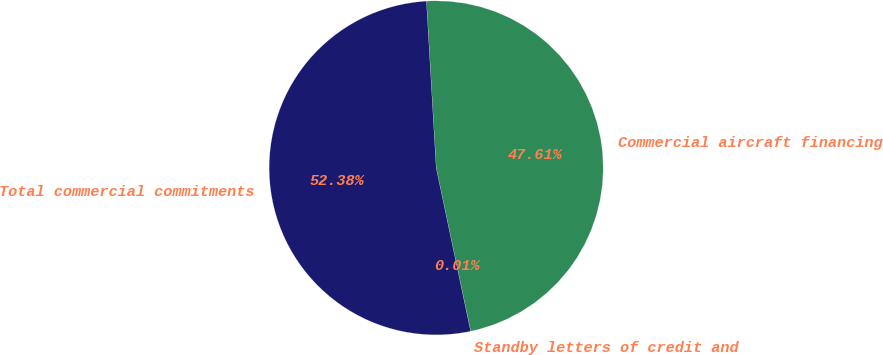Convert chart to OTSL. <chart><loc_0><loc_0><loc_500><loc_500><pie_chart><fcel>Standby letters of credit and<fcel>Commercial aircraft financing<fcel>Total commercial commitments<nl><fcel>0.01%<fcel>47.61%<fcel>52.37%<nl></chart> 